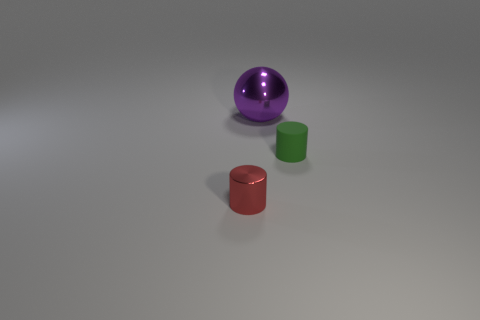Add 1 big purple balls. How many objects exist? 4 Subtract all cylinders. How many objects are left? 1 Add 2 tiny green cylinders. How many tiny green cylinders are left? 3 Add 3 green spheres. How many green spheres exist? 3 Subtract 0 green spheres. How many objects are left? 3 Subtract all large brown balls. Subtract all green rubber things. How many objects are left? 2 